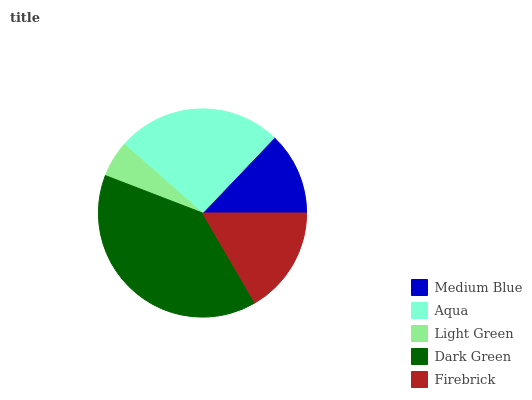Is Light Green the minimum?
Answer yes or no. Yes. Is Dark Green the maximum?
Answer yes or no. Yes. Is Aqua the minimum?
Answer yes or no. No. Is Aqua the maximum?
Answer yes or no. No. Is Aqua greater than Medium Blue?
Answer yes or no. Yes. Is Medium Blue less than Aqua?
Answer yes or no. Yes. Is Medium Blue greater than Aqua?
Answer yes or no. No. Is Aqua less than Medium Blue?
Answer yes or no. No. Is Firebrick the high median?
Answer yes or no. Yes. Is Firebrick the low median?
Answer yes or no. Yes. Is Dark Green the high median?
Answer yes or no. No. Is Aqua the low median?
Answer yes or no. No. 